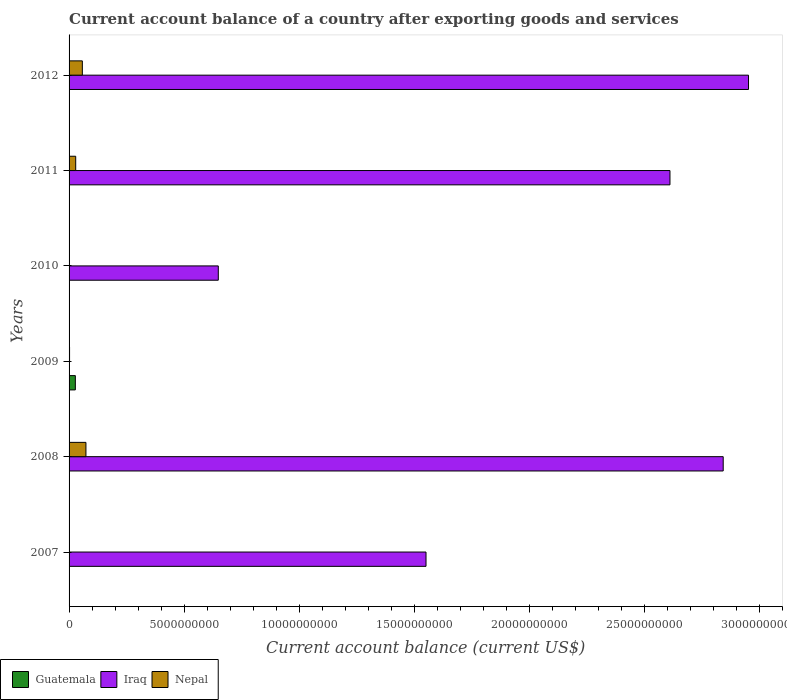Are the number of bars on each tick of the Y-axis equal?
Your response must be concise. No. How many bars are there on the 6th tick from the top?
Keep it short and to the point. 2. What is the label of the 4th group of bars from the top?
Make the answer very short. 2009. What is the account balance in Guatemala in 2008?
Keep it short and to the point. 0. Across all years, what is the maximum account balance in Nepal?
Provide a short and direct response. 7.33e+08. What is the total account balance in Guatemala in the graph?
Offer a very short reply. 2.73e+08. What is the difference between the account balance in Iraq in 2008 and that in 2012?
Offer a terse response. -1.10e+09. What is the difference between the account balance in Iraq in 2008 and the account balance in Nepal in 2012?
Provide a succinct answer. 2.79e+1. What is the average account balance in Iraq per year?
Provide a short and direct response. 1.77e+1. In the year 2009, what is the difference between the account balance in Guatemala and account balance in Nepal?
Provide a succinct answer. 2.51e+08. What is the ratio of the account balance in Nepal in 2007 to that in 2012?
Your response must be concise. 0.01. Is the account balance in Iraq in 2008 less than that in 2012?
Ensure brevity in your answer.  Yes. What is the difference between the highest and the second highest account balance in Nepal?
Your answer should be compact. 1.56e+08. What is the difference between the highest and the lowest account balance in Guatemala?
Your answer should be compact. 2.73e+08. Is the sum of the account balance in Nepal in 2011 and 2012 greater than the maximum account balance in Iraq across all years?
Your answer should be very brief. No. How many bars are there?
Your response must be concise. 11. Are all the bars in the graph horizontal?
Your response must be concise. Yes. What is the difference between two consecutive major ticks on the X-axis?
Your response must be concise. 5.00e+09. Are the values on the major ticks of X-axis written in scientific E-notation?
Offer a terse response. No. Does the graph contain any zero values?
Ensure brevity in your answer.  Yes. Where does the legend appear in the graph?
Provide a short and direct response. Bottom left. What is the title of the graph?
Give a very brief answer. Current account balance of a country after exporting goods and services. Does "Nicaragua" appear as one of the legend labels in the graph?
Ensure brevity in your answer.  No. What is the label or title of the X-axis?
Your answer should be compact. Current account balance (current US$). What is the label or title of the Y-axis?
Your response must be concise. Years. What is the Current account balance (current US$) in Iraq in 2007?
Keep it short and to the point. 1.55e+1. What is the Current account balance (current US$) of Nepal in 2007?
Your answer should be compact. 5.66e+06. What is the Current account balance (current US$) in Guatemala in 2008?
Provide a succinct answer. 0. What is the Current account balance (current US$) in Iraq in 2008?
Your answer should be very brief. 2.84e+1. What is the Current account balance (current US$) in Nepal in 2008?
Your response must be concise. 7.33e+08. What is the Current account balance (current US$) of Guatemala in 2009?
Keep it short and to the point. 2.73e+08. What is the Current account balance (current US$) of Nepal in 2009?
Offer a terse response. 2.14e+07. What is the Current account balance (current US$) of Guatemala in 2010?
Provide a short and direct response. 0. What is the Current account balance (current US$) of Iraq in 2010?
Ensure brevity in your answer.  6.49e+09. What is the Current account balance (current US$) of Guatemala in 2011?
Provide a succinct answer. 0. What is the Current account balance (current US$) in Iraq in 2011?
Your answer should be compact. 2.61e+1. What is the Current account balance (current US$) in Nepal in 2011?
Offer a very short reply. 2.89e+08. What is the Current account balance (current US$) of Guatemala in 2012?
Give a very brief answer. 0. What is the Current account balance (current US$) in Iraq in 2012?
Your answer should be compact. 2.95e+1. What is the Current account balance (current US$) of Nepal in 2012?
Your answer should be very brief. 5.77e+08. Across all years, what is the maximum Current account balance (current US$) in Guatemala?
Provide a short and direct response. 2.73e+08. Across all years, what is the maximum Current account balance (current US$) in Iraq?
Provide a short and direct response. 2.95e+1. Across all years, what is the maximum Current account balance (current US$) in Nepal?
Keep it short and to the point. 7.33e+08. Across all years, what is the minimum Current account balance (current US$) in Guatemala?
Provide a short and direct response. 0. Across all years, what is the minimum Current account balance (current US$) in Iraq?
Offer a terse response. 0. Across all years, what is the minimum Current account balance (current US$) of Nepal?
Offer a very short reply. 0. What is the total Current account balance (current US$) of Guatemala in the graph?
Ensure brevity in your answer.  2.73e+08. What is the total Current account balance (current US$) of Iraq in the graph?
Provide a succinct answer. 1.06e+11. What is the total Current account balance (current US$) in Nepal in the graph?
Make the answer very short. 1.63e+09. What is the difference between the Current account balance (current US$) of Iraq in 2007 and that in 2008?
Provide a succinct answer. -1.29e+1. What is the difference between the Current account balance (current US$) in Nepal in 2007 and that in 2008?
Offer a very short reply. -7.28e+08. What is the difference between the Current account balance (current US$) in Nepal in 2007 and that in 2009?
Make the answer very short. -1.58e+07. What is the difference between the Current account balance (current US$) in Iraq in 2007 and that in 2010?
Ensure brevity in your answer.  9.03e+09. What is the difference between the Current account balance (current US$) in Iraq in 2007 and that in 2011?
Offer a terse response. -1.06e+1. What is the difference between the Current account balance (current US$) in Nepal in 2007 and that in 2011?
Offer a terse response. -2.83e+08. What is the difference between the Current account balance (current US$) of Iraq in 2007 and that in 2012?
Offer a very short reply. -1.40e+1. What is the difference between the Current account balance (current US$) of Nepal in 2007 and that in 2012?
Your answer should be compact. -5.71e+08. What is the difference between the Current account balance (current US$) in Nepal in 2008 and that in 2009?
Keep it short and to the point. 7.12e+08. What is the difference between the Current account balance (current US$) in Iraq in 2008 and that in 2010?
Make the answer very short. 2.20e+1. What is the difference between the Current account balance (current US$) in Iraq in 2008 and that in 2011?
Keep it short and to the point. 2.31e+09. What is the difference between the Current account balance (current US$) of Nepal in 2008 and that in 2011?
Ensure brevity in your answer.  4.45e+08. What is the difference between the Current account balance (current US$) in Iraq in 2008 and that in 2012?
Your answer should be compact. -1.10e+09. What is the difference between the Current account balance (current US$) of Nepal in 2008 and that in 2012?
Your answer should be compact. 1.56e+08. What is the difference between the Current account balance (current US$) in Nepal in 2009 and that in 2011?
Provide a short and direct response. -2.67e+08. What is the difference between the Current account balance (current US$) of Nepal in 2009 and that in 2012?
Offer a terse response. -5.56e+08. What is the difference between the Current account balance (current US$) of Iraq in 2010 and that in 2011?
Your answer should be very brief. -1.96e+1. What is the difference between the Current account balance (current US$) in Iraq in 2010 and that in 2012?
Give a very brief answer. -2.31e+1. What is the difference between the Current account balance (current US$) in Iraq in 2011 and that in 2012?
Your answer should be compact. -3.42e+09. What is the difference between the Current account balance (current US$) of Nepal in 2011 and that in 2012?
Make the answer very short. -2.88e+08. What is the difference between the Current account balance (current US$) in Iraq in 2007 and the Current account balance (current US$) in Nepal in 2008?
Keep it short and to the point. 1.48e+1. What is the difference between the Current account balance (current US$) in Iraq in 2007 and the Current account balance (current US$) in Nepal in 2009?
Give a very brief answer. 1.55e+1. What is the difference between the Current account balance (current US$) of Iraq in 2007 and the Current account balance (current US$) of Nepal in 2011?
Offer a terse response. 1.52e+1. What is the difference between the Current account balance (current US$) in Iraq in 2007 and the Current account balance (current US$) in Nepal in 2012?
Give a very brief answer. 1.49e+1. What is the difference between the Current account balance (current US$) of Iraq in 2008 and the Current account balance (current US$) of Nepal in 2009?
Your answer should be very brief. 2.84e+1. What is the difference between the Current account balance (current US$) of Iraq in 2008 and the Current account balance (current US$) of Nepal in 2011?
Provide a succinct answer. 2.82e+1. What is the difference between the Current account balance (current US$) of Iraq in 2008 and the Current account balance (current US$) of Nepal in 2012?
Offer a terse response. 2.79e+1. What is the difference between the Current account balance (current US$) in Guatemala in 2009 and the Current account balance (current US$) in Iraq in 2010?
Make the answer very short. -6.22e+09. What is the difference between the Current account balance (current US$) in Guatemala in 2009 and the Current account balance (current US$) in Iraq in 2011?
Offer a terse response. -2.59e+1. What is the difference between the Current account balance (current US$) of Guatemala in 2009 and the Current account balance (current US$) of Nepal in 2011?
Offer a terse response. -1.58e+07. What is the difference between the Current account balance (current US$) of Guatemala in 2009 and the Current account balance (current US$) of Iraq in 2012?
Offer a terse response. -2.93e+1. What is the difference between the Current account balance (current US$) of Guatemala in 2009 and the Current account balance (current US$) of Nepal in 2012?
Provide a short and direct response. -3.04e+08. What is the difference between the Current account balance (current US$) of Iraq in 2010 and the Current account balance (current US$) of Nepal in 2011?
Ensure brevity in your answer.  6.20e+09. What is the difference between the Current account balance (current US$) in Iraq in 2010 and the Current account balance (current US$) in Nepal in 2012?
Ensure brevity in your answer.  5.91e+09. What is the difference between the Current account balance (current US$) of Iraq in 2011 and the Current account balance (current US$) of Nepal in 2012?
Your answer should be compact. 2.55e+1. What is the average Current account balance (current US$) of Guatemala per year?
Offer a very short reply. 4.55e+07. What is the average Current account balance (current US$) of Iraq per year?
Your answer should be compact. 1.77e+1. What is the average Current account balance (current US$) of Nepal per year?
Keep it short and to the point. 2.71e+08. In the year 2007, what is the difference between the Current account balance (current US$) of Iraq and Current account balance (current US$) of Nepal?
Keep it short and to the point. 1.55e+1. In the year 2008, what is the difference between the Current account balance (current US$) of Iraq and Current account balance (current US$) of Nepal?
Give a very brief answer. 2.77e+1. In the year 2009, what is the difference between the Current account balance (current US$) in Guatemala and Current account balance (current US$) in Nepal?
Your answer should be compact. 2.51e+08. In the year 2011, what is the difference between the Current account balance (current US$) in Iraq and Current account balance (current US$) in Nepal?
Offer a terse response. 2.58e+1. In the year 2012, what is the difference between the Current account balance (current US$) in Iraq and Current account balance (current US$) in Nepal?
Provide a short and direct response. 2.90e+1. What is the ratio of the Current account balance (current US$) of Iraq in 2007 to that in 2008?
Offer a terse response. 0.55. What is the ratio of the Current account balance (current US$) in Nepal in 2007 to that in 2008?
Provide a short and direct response. 0.01. What is the ratio of the Current account balance (current US$) of Nepal in 2007 to that in 2009?
Keep it short and to the point. 0.26. What is the ratio of the Current account balance (current US$) of Iraq in 2007 to that in 2010?
Keep it short and to the point. 2.39. What is the ratio of the Current account balance (current US$) of Iraq in 2007 to that in 2011?
Your answer should be very brief. 0.59. What is the ratio of the Current account balance (current US$) in Nepal in 2007 to that in 2011?
Keep it short and to the point. 0.02. What is the ratio of the Current account balance (current US$) of Iraq in 2007 to that in 2012?
Keep it short and to the point. 0.53. What is the ratio of the Current account balance (current US$) in Nepal in 2007 to that in 2012?
Ensure brevity in your answer.  0.01. What is the ratio of the Current account balance (current US$) of Nepal in 2008 to that in 2009?
Ensure brevity in your answer.  34.25. What is the ratio of the Current account balance (current US$) of Iraq in 2008 to that in 2010?
Provide a short and direct response. 4.38. What is the ratio of the Current account balance (current US$) in Iraq in 2008 to that in 2011?
Your answer should be very brief. 1.09. What is the ratio of the Current account balance (current US$) of Nepal in 2008 to that in 2011?
Your response must be concise. 2.54. What is the ratio of the Current account balance (current US$) of Iraq in 2008 to that in 2012?
Keep it short and to the point. 0.96. What is the ratio of the Current account balance (current US$) in Nepal in 2008 to that in 2012?
Ensure brevity in your answer.  1.27. What is the ratio of the Current account balance (current US$) of Nepal in 2009 to that in 2011?
Provide a succinct answer. 0.07. What is the ratio of the Current account balance (current US$) in Nepal in 2009 to that in 2012?
Provide a short and direct response. 0.04. What is the ratio of the Current account balance (current US$) of Iraq in 2010 to that in 2011?
Give a very brief answer. 0.25. What is the ratio of the Current account balance (current US$) of Iraq in 2010 to that in 2012?
Provide a succinct answer. 0.22. What is the ratio of the Current account balance (current US$) in Iraq in 2011 to that in 2012?
Provide a succinct answer. 0.88. What is the ratio of the Current account balance (current US$) in Nepal in 2011 to that in 2012?
Your answer should be very brief. 0.5. What is the difference between the highest and the second highest Current account balance (current US$) of Iraq?
Make the answer very short. 1.10e+09. What is the difference between the highest and the second highest Current account balance (current US$) of Nepal?
Provide a succinct answer. 1.56e+08. What is the difference between the highest and the lowest Current account balance (current US$) of Guatemala?
Give a very brief answer. 2.73e+08. What is the difference between the highest and the lowest Current account balance (current US$) in Iraq?
Offer a terse response. 2.95e+1. What is the difference between the highest and the lowest Current account balance (current US$) of Nepal?
Offer a very short reply. 7.33e+08. 